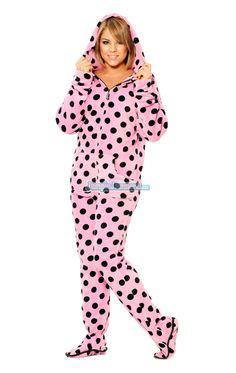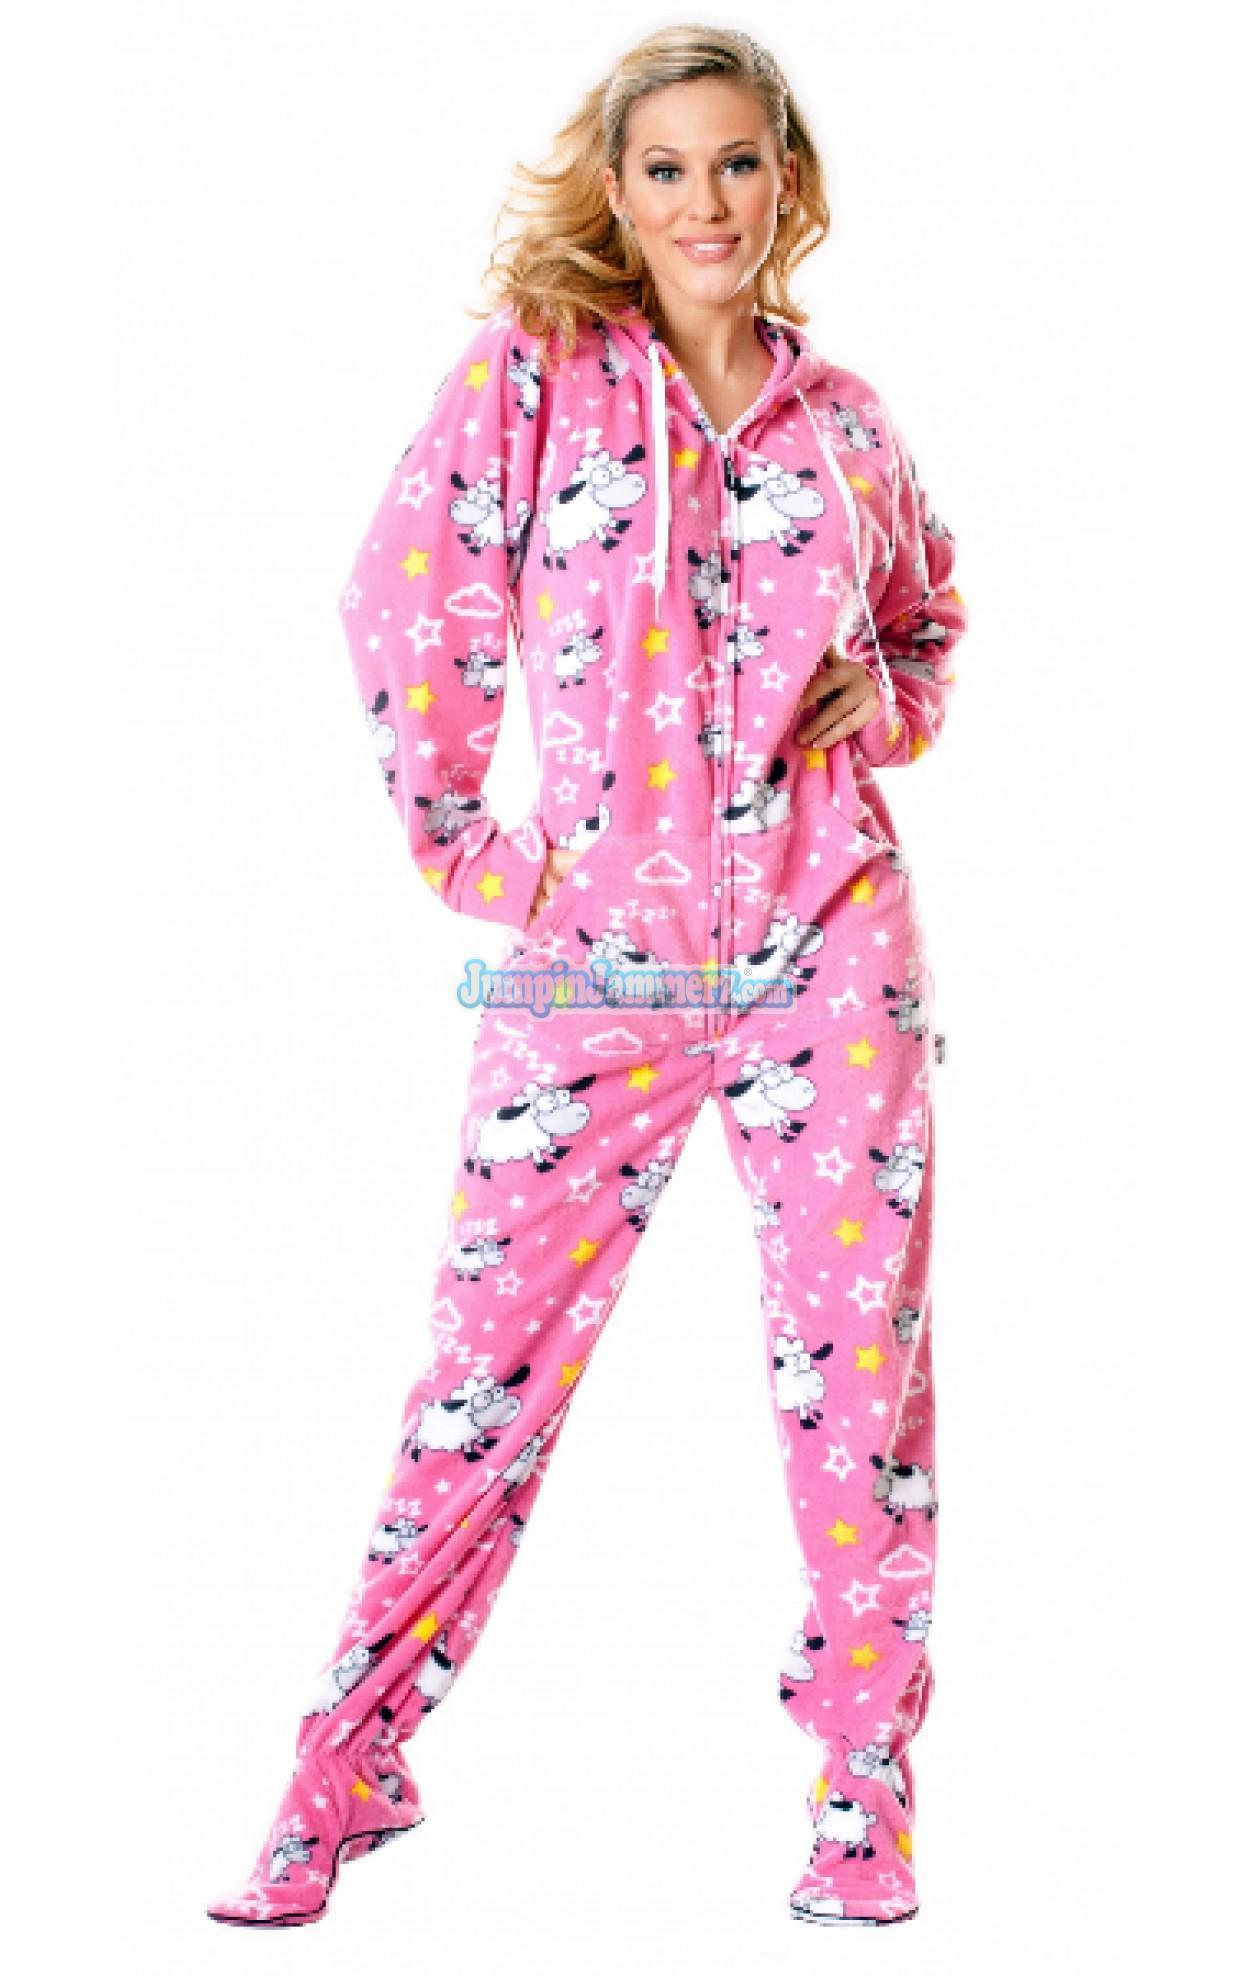The first image is the image on the left, the second image is the image on the right. Given the left and right images, does the statement "Two women are wearing footed pajamas, one of them with the attached hood pulled over her head." hold true? Answer yes or no. Yes. The first image is the image on the left, the second image is the image on the right. Examine the images to the left and right. Is the description "Both images must be females." accurate? Answer yes or no. Yes. 